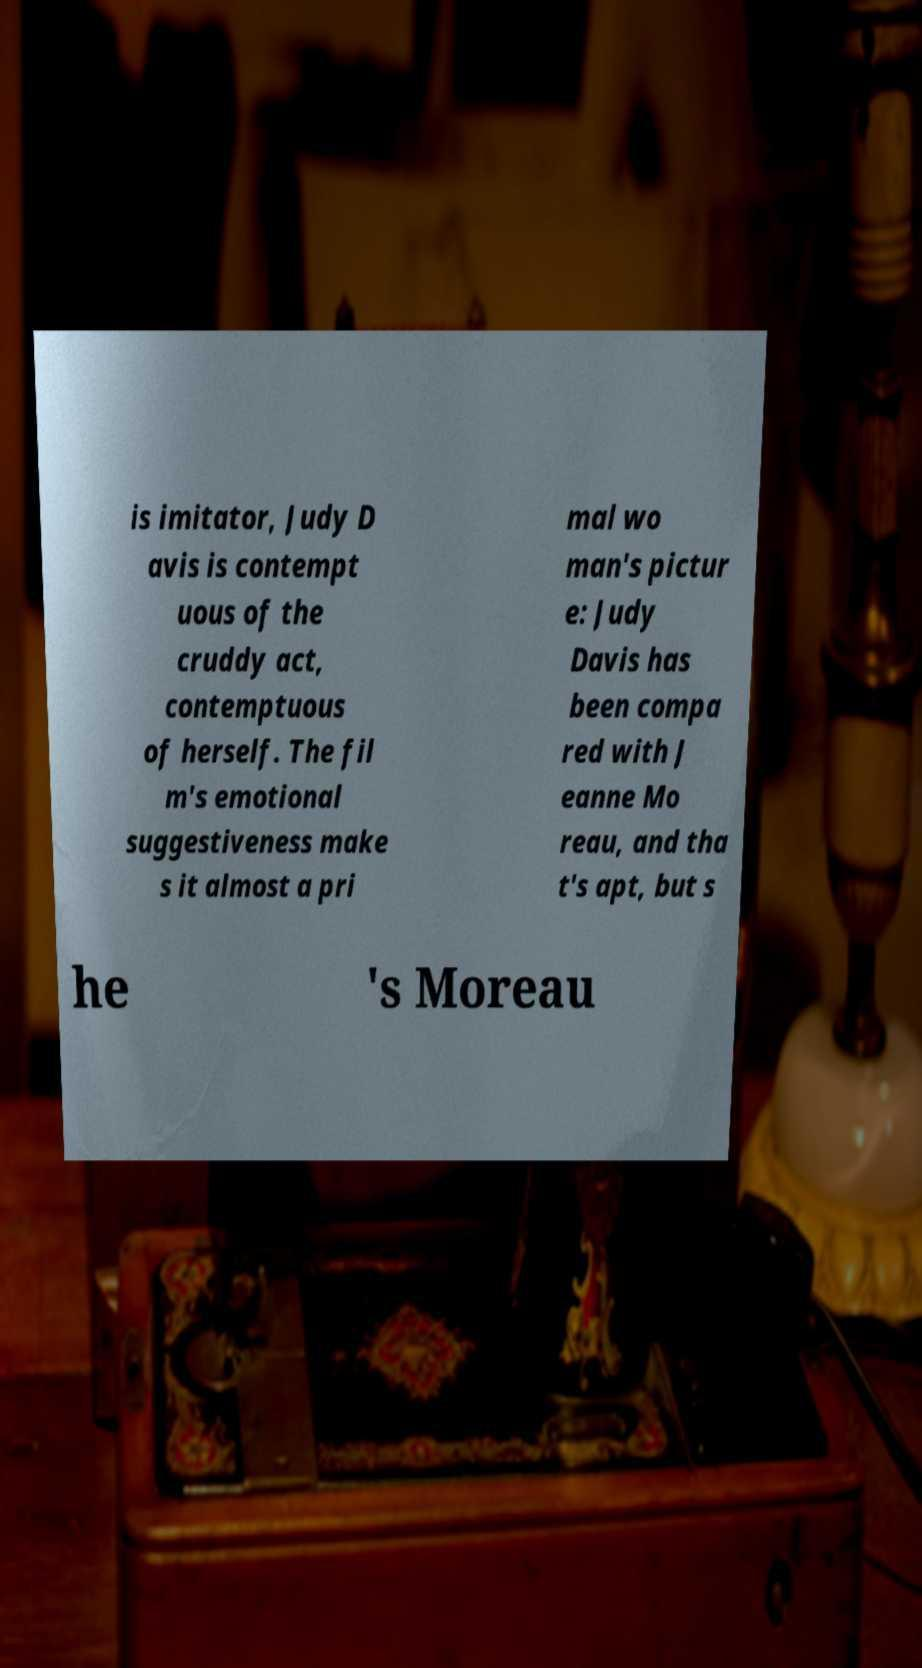Can you read and provide the text displayed in the image?This photo seems to have some interesting text. Can you extract and type it out for me? is imitator, Judy D avis is contempt uous of the cruddy act, contemptuous of herself. The fil m's emotional suggestiveness make s it almost a pri mal wo man's pictur e: Judy Davis has been compa red with J eanne Mo reau, and tha t's apt, but s he 's Moreau 